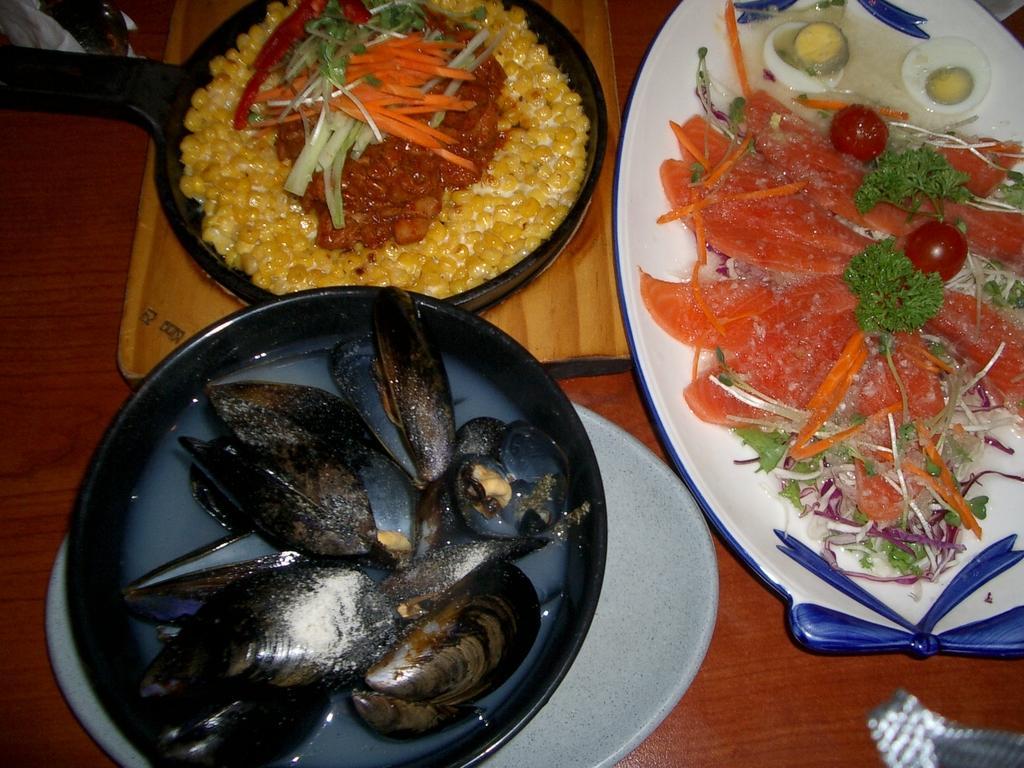Can you describe this image briefly? This picture describe about some food in the three plates is placed on the wooden table top. In front we can see vegetable salad in the white platter. Beside we can see some seafood in the black plate. 